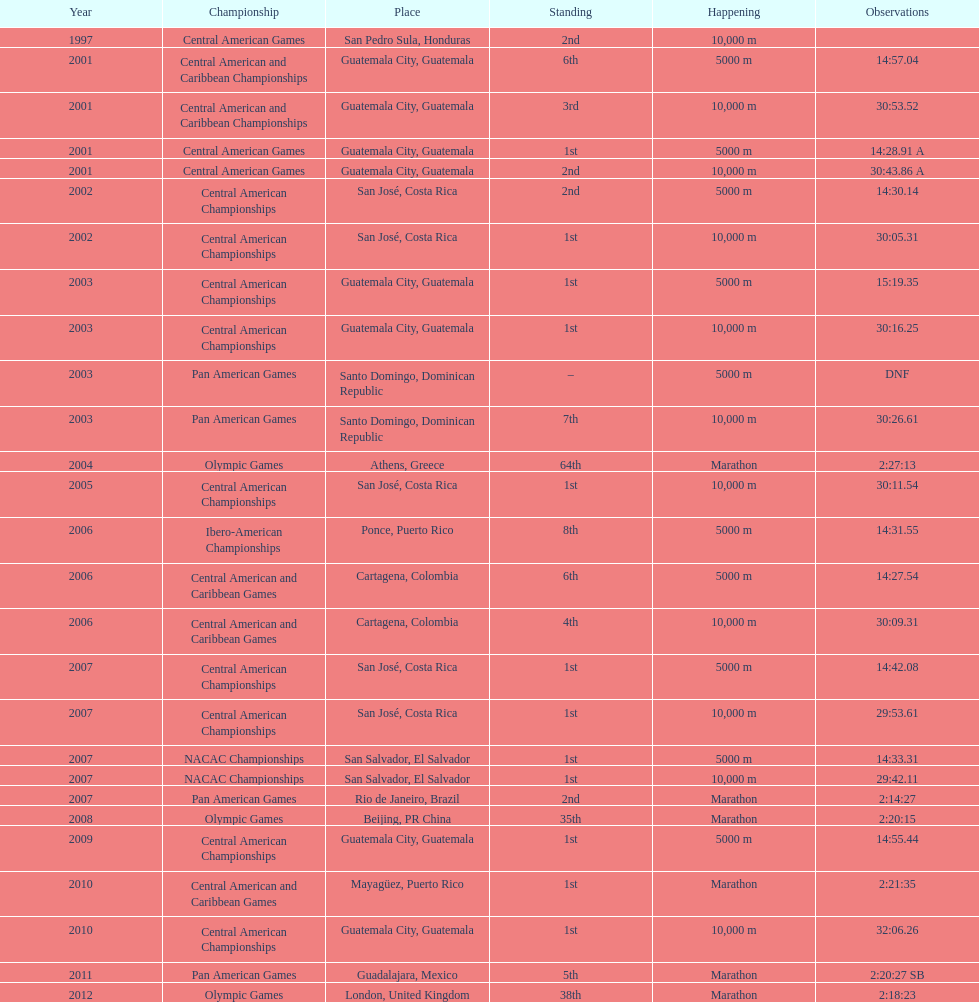What was the last competition in which a position of "2nd" was achieved? Pan American Games. I'm looking to parse the entire table for insights. Could you assist me with that? {'header': ['Year', 'Championship', 'Place', 'Standing', 'Happening', 'Observations'], 'rows': [['1997', 'Central American Games', 'San Pedro Sula, Honduras', '2nd', '10,000 m', ''], ['2001', 'Central American and Caribbean Championships', 'Guatemala City, Guatemala', '6th', '5000 m', '14:57.04'], ['2001', 'Central American and Caribbean Championships', 'Guatemala City, Guatemala', '3rd', '10,000 m', '30:53.52'], ['2001', 'Central American Games', 'Guatemala City, Guatemala', '1st', '5000 m', '14:28.91 A'], ['2001', 'Central American Games', 'Guatemala City, Guatemala', '2nd', '10,000 m', '30:43.86 A'], ['2002', 'Central American Championships', 'San José, Costa Rica', '2nd', '5000 m', '14:30.14'], ['2002', 'Central American Championships', 'San José, Costa Rica', '1st', '10,000 m', '30:05.31'], ['2003', 'Central American Championships', 'Guatemala City, Guatemala', '1st', '5000 m', '15:19.35'], ['2003', 'Central American Championships', 'Guatemala City, Guatemala', '1st', '10,000 m', '30:16.25'], ['2003', 'Pan American Games', 'Santo Domingo, Dominican Republic', '–', '5000 m', 'DNF'], ['2003', 'Pan American Games', 'Santo Domingo, Dominican Republic', '7th', '10,000 m', '30:26.61'], ['2004', 'Olympic Games', 'Athens, Greece', '64th', 'Marathon', '2:27:13'], ['2005', 'Central American Championships', 'San José, Costa Rica', '1st', '10,000 m', '30:11.54'], ['2006', 'Ibero-American Championships', 'Ponce, Puerto Rico', '8th', '5000 m', '14:31.55'], ['2006', 'Central American and Caribbean Games', 'Cartagena, Colombia', '6th', '5000 m', '14:27.54'], ['2006', 'Central American and Caribbean Games', 'Cartagena, Colombia', '4th', '10,000 m', '30:09.31'], ['2007', 'Central American Championships', 'San José, Costa Rica', '1st', '5000 m', '14:42.08'], ['2007', 'Central American Championships', 'San José, Costa Rica', '1st', '10,000 m', '29:53.61'], ['2007', 'NACAC Championships', 'San Salvador, El Salvador', '1st', '5000 m', '14:33.31'], ['2007', 'NACAC Championships', 'San Salvador, El Salvador', '1st', '10,000 m', '29:42.11'], ['2007', 'Pan American Games', 'Rio de Janeiro, Brazil', '2nd', 'Marathon', '2:14:27'], ['2008', 'Olympic Games', 'Beijing, PR China', '35th', 'Marathon', '2:20:15'], ['2009', 'Central American Championships', 'Guatemala City, Guatemala', '1st', '5000 m', '14:55.44'], ['2010', 'Central American and Caribbean Games', 'Mayagüez, Puerto Rico', '1st', 'Marathon', '2:21:35'], ['2010', 'Central American Championships', 'Guatemala City, Guatemala', '1st', '10,000 m', '32:06.26'], ['2011', 'Pan American Games', 'Guadalajara, Mexico', '5th', 'Marathon', '2:20:27 SB'], ['2012', 'Olympic Games', 'London, United Kingdom', '38th', 'Marathon', '2:18:23']]} 